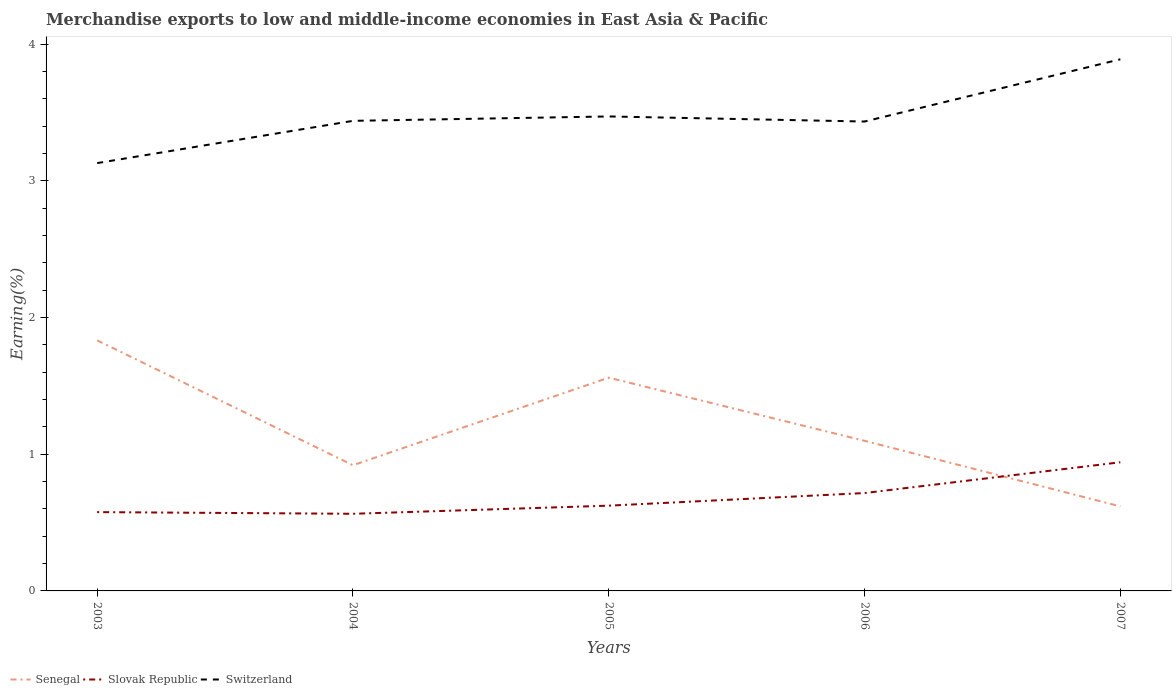How many different coloured lines are there?
Provide a succinct answer. 3. Does the line corresponding to Slovak Republic intersect with the line corresponding to Senegal?
Ensure brevity in your answer.  Yes. Is the number of lines equal to the number of legend labels?
Ensure brevity in your answer.  Yes. Across all years, what is the maximum percentage of amount earned from merchandise exports in Senegal?
Keep it short and to the point. 0.62. What is the total percentage of amount earned from merchandise exports in Switzerland in the graph?
Ensure brevity in your answer.  -0.46. What is the difference between the highest and the second highest percentage of amount earned from merchandise exports in Switzerland?
Provide a short and direct response. 0.76. What is the difference between two consecutive major ticks on the Y-axis?
Your response must be concise. 1. Where does the legend appear in the graph?
Offer a terse response. Bottom left. How many legend labels are there?
Make the answer very short. 3. How are the legend labels stacked?
Offer a very short reply. Horizontal. What is the title of the graph?
Keep it short and to the point. Merchandise exports to low and middle-income economies in East Asia & Pacific. What is the label or title of the X-axis?
Provide a short and direct response. Years. What is the label or title of the Y-axis?
Provide a short and direct response. Earning(%). What is the Earning(%) of Senegal in 2003?
Your response must be concise. 1.83. What is the Earning(%) in Slovak Republic in 2003?
Offer a terse response. 0.58. What is the Earning(%) in Switzerland in 2003?
Ensure brevity in your answer.  3.13. What is the Earning(%) of Senegal in 2004?
Ensure brevity in your answer.  0.92. What is the Earning(%) of Slovak Republic in 2004?
Ensure brevity in your answer.  0.56. What is the Earning(%) of Switzerland in 2004?
Your response must be concise. 3.44. What is the Earning(%) of Senegal in 2005?
Your answer should be very brief. 1.56. What is the Earning(%) of Slovak Republic in 2005?
Provide a short and direct response. 0.62. What is the Earning(%) of Switzerland in 2005?
Ensure brevity in your answer.  3.47. What is the Earning(%) in Senegal in 2006?
Provide a succinct answer. 1.1. What is the Earning(%) in Slovak Republic in 2006?
Give a very brief answer. 0.72. What is the Earning(%) of Switzerland in 2006?
Ensure brevity in your answer.  3.43. What is the Earning(%) of Senegal in 2007?
Your response must be concise. 0.62. What is the Earning(%) in Slovak Republic in 2007?
Your response must be concise. 0.94. What is the Earning(%) in Switzerland in 2007?
Make the answer very short. 3.89. Across all years, what is the maximum Earning(%) of Senegal?
Keep it short and to the point. 1.83. Across all years, what is the maximum Earning(%) of Slovak Republic?
Provide a short and direct response. 0.94. Across all years, what is the maximum Earning(%) of Switzerland?
Your answer should be very brief. 3.89. Across all years, what is the minimum Earning(%) of Senegal?
Your answer should be compact. 0.62. Across all years, what is the minimum Earning(%) in Slovak Republic?
Make the answer very short. 0.56. Across all years, what is the minimum Earning(%) of Switzerland?
Your answer should be compact. 3.13. What is the total Earning(%) of Senegal in the graph?
Give a very brief answer. 6.03. What is the total Earning(%) of Slovak Republic in the graph?
Your answer should be compact. 3.42. What is the total Earning(%) of Switzerland in the graph?
Your answer should be compact. 17.36. What is the difference between the Earning(%) in Senegal in 2003 and that in 2004?
Your answer should be compact. 0.91. What is the difference between the Earning(%) of Slovak Republic in 2003 and that in 2004?
Ensure brevity in your answer.  0.01. What is the difference between the Earning(%) in Switzerland in 2003 and that in 2004?
Provide a succinct answer. -0.31. What is the difference between the Earning(%) in Senegal in 2003 and that in 2005?
Offer a very short reply. 0.27. What is the difference between the Earning(%) of Slovak Republic in 2003 and that in 2005?
Offer a terse response. -0.05. What is the difference between the Earning(%) in Switzerland in 2003 and that in 2005?
Make the answer very short. -0.34. What is the difference between the Earning(%) of Senegal in 2003 and that in 2006?
Provide a succinct answer. 0.73. What is the difference between the Earning(%) of Slovak Republic in 2003 and that in 2006?
Give a very brief answer. -0.14. What is the difference between the Earning(%) of Switzerland in 2003 and that in 2006?
Your response must be concise. -0.3. What is the difference between the Earning(%) of Senegal in 2003 and that in 2007?
Give a very brief answer. 1.21. What is the difference between the Earning(%) of Slovak Republic in 2003 and that in 2007?
Your response must be concise. -0.36. What is the difference between the Earning(%) of Switzerland in 2003 and that in 2007?
Your answer should be very brief. -0.76. What is the difference between the Earning(%) in Senegal in 2004 and that in 2005?
Ensure brevity in your answer.  -0.64. What is the difference between the Earning(%) in Slovak Republic in 2004 and that in 2005?
Provide a short and direct response. -0.06. What is the difference between the Earning(%) of Switzerland in 2004 and that in 2005?
Make the answer very short. -0.03. What is the difference between the Earning(%) in Senegal in 2004 and that in 2006?
Provide a succinct answer. -0.18. What is the difference between the Earning(%) of Slovak Republic in 2004 and that in 2006?
Offer a very short reply. -0.15. What is the difference between the Earning(%) in Switzerland in 2004 and that in 2006?
Your answer should be compact. 0.01. What is the difference between the Earning(%) in Senegal in 2004 and that in 2007?
Keep it short and to the point. 0.3. What is the difference between the Earning(%) of Slovak Republic in 2004 and that in 2007?
Give a very brief answer. -0.38. What is the difference between the Earning(%) of Switzerland in 2004 and that in 2007?
Ensure brevity in your answer.  -0.45. What is the difference between the Earning(%) in Senegal in 2005 and that in 2006?
Ensure brevity in your answer.  0.46. What is the difference between the Earning(%) in Slovak Republic in 2005 and that in 2006?
Provide a short and direct response. -0.09. What is the difference between the Earning(%) of Switzerland in 2005 and that in 2006?
Make the answer very short. 0.04. What is the difference between the Earning(%) of Senegal in 2005 and that in 2007?
Offer a very short reply. 0.94. What is the difference between the Earning(%) in Slovak Republic in 2005 and that in 2007?
Offer a terse response. -0.32. What is the difference between the Earning(%) of Switzerland in 2005 and that in 2007?
Your answer should be very brief. -0.42. What is the difference between the Earning(%) of Senegal in 2006 and that in 2007?
Your answer should be very brief. 0.48. What is the difference between the Earning(%) in Slovak Republic in 2006 and that in 2007?
Make the answer very short. -0.23. What is the difference between the Earning(%) of Switzerland in 2006 and that in 2007?
Provide a succinct answer. -0.46. What is the difference between the Earning(%) in Senegal in 2003 and the Earning(%) in Slovak Republic in 2004?
Your answer should be compact. 1.27. What is the difference between the Earning(%) in Senegal in 2003 and the Earning(%) in Switzerland in 2004?
Ensure brevity in your answer.  -1.61. What is the difference between the Earning(%) in Slovak Republic in 2003 and the Earning(%) in Switzerland in 2004?
Offer a terse response. -2.86. What is the difference between the Earning(%) in Senegal in 2003 and the Earning(%) in Slovak Republic in 2005?
Offer a terse response. 1.21. What is the difference between the Earning(%) of Senegal in 2003 and the Earning(%) of Switzerland in 2005?
Offer a terse response. -1.64. What is the difference between the Earning(%) of Slovak Republic in 2003 and the Earning(%) of Switzerland in 2005?
Ensure brevity in your answer.  -2.89. What is the difference between the Earning(%) in Senegal in 2003 and the Earning(%) in Slovak Republic in 2006?
Offer a terse response. 1.12. What is the difference between the Earning(%) in Senegal in 2003 and the Earning(%) in Switzerland in 2006?
Offer a terse response. -1.6. What is the difference between the Earning(%) of Slovak Republic in 2003 and the Earning(%) of Switzerland in 2006?
Your response must be concise. -2.86. What is the difference between the Earning(%) of Senegal in 2003 and the Earning(%) of Slovak Republic in 2007?
Your response must be concise. 0.89. What is the difference between the Earning(%) of Senegal in 2003 and the Earning(%) of Switzerland in 2007?
Offer a terse response. -2.06. What is the difference between the Earning(%) of Slovak Republic in 2003 and the Earning(%) of Switzerland in 2007?
Offer a terse response. -3.31. What is the difference between the Earning(%) of Senegal in 2004 and the Earning(%) of Slovak Republic in 2005?
Provide a short and direct response. 0.3. What is the difference between the Earning(%) in Senegal in 2004 and the Earning(%) in Switzerland in 2005?
Your answer should be very brief. -2.55. What is the difference between the Earning(%) in Slovak Republic in 2004 and the Earning(%) in Switzerland in 2005?
Make the answer very short. -2.91. What is the difference between the Earning(%) in Senegal in 2004 and the Earning(%) in Slovak Republic in 2006?
Offer a very short reply. 0.2. What is the difference between the Earning(%) in Senegal in 2004 and the Earning(%) in Switzerland in 2006?
Your response must be concise. -2.51. What is the difference between the Earning(%) of Slovak Republic in 2004 and the Earning(%) of Switzerland in 2006?
Offer a terse response. -2.87. What is the difference between the Earning(%) in Senegal in 2004 and the Earning(%) in Slovak Republic in 2007?
Offer a terse response. -0.02. What is the difference between the Earning(%) in Senegal in 2004 and the Earning(%) in Switzerland in 2007?
Offer a terse response. -2.97. What is the difference between the Earning(%) in Slovak Republic in 2004 and the Earning(%) in Switzerland in 2007?
Your answer should be very brief. -3.32. What is the difference between the Earning(%) in Senegal in 2005 and the Earning(%) in Slovak Republic in 2006?
Make the answer very short. 0.84. What is the difference between the Earning(%) of Senegal in 2005 and the Earning(%) of Switzerland in 2006?
Your answer should be very brief. -1.87. What is the difference between the Earning(%) of Slovak Republic in 2005 and the Earning(%) of Switzerland in 2006?
Offer a terse response. -2.81. What is the difference between the Earning(%) in Senegal in 2005 and the Earning(%) in Slovak Republic in 2007?
Give a very brief answer. 0.62. What is the difference between the Earning(%) of Senegal in 2005 and the Earning(%) of Switzerland in 2007?
Offer a terse response. -2.33. What is the difference between the Earning(%) in Slovak Republic in 2005 and the Earning(%) in Switzerland in 2007?
Ensure brevity in your answer.  -3.27. What is the difference between the Earning(%) of Senegal in 2006 and the Earning(%) of Slovak Republic in 2007?
Provide a succinct answer. 0.16. What is the difference between the Earning(%) in Senegal in 2006 and the Earning(%) in Switzerland in 2007?
Make the answer very short. -2.79. What is the difference between the Earning(%) in Slovak Republic in 2006 and the Earning(%) in Switzerland in 2007?
Provide a succinct answer. -3.17. What is the average Earning(%) of Senegal per year?
Ensure brevity in your answer.  1.21. What is the average Earning(%) of Slovak Republic per year?
Your response must be concise. 0.68. What is the average Earning(%) of Switzerland per year?
Offer a very short reply. 3.47. In the year 2003, what is the difference between the Earning(%) of Senegal and Earning(%) of Slovak Republic?
Your response must be concise. 1.26. In the year 2003, what is the difference between the Earning(%) in Senegal and Earning(%) in Switzerland?
Give a very brief answer. -1.3. In the year 2003, what is the difference between the Earning(%) of Slovak Republic and Earning(%) of Switzerland?
Your response must be concise. -2.55. In the year 2004, what is the difference between the Earning(%) of Senegal and Earning(%) of Slovak Republic?
Make the answer very short. 0.36. In the year 2004, what is the difference between the Earning(%) of Senegal and Earning(%) of Switzerland?
Ensure brevity in your answer.  -2.52. In the year 2004, what is the difference between the Earning(%) in Slovak Republic and Earning(%) in Switzerland?
Ensure brevity in your answer.  -2.87. In the year 2005, what is the difference between the Earning(%) of Senegal and Earning(%) of Slovak Republic?
Provide a short and direct response. 0.94. In the year 2005, what is the difference between the Earning(%) of Senegal and Earning(%) of Switzerland?
Make the answer very short. -1.91. In the year 2005, what is the difference between the Earning(%) in Slovak Republic and Earning(%) in Switzerland?
Offer a terse response. -2.85. In the year 2006, what is the difference between the Earning(%) in Senegal and Earning(%) in Slovak Republic?
Your answer should be compact. 0.38. In the year 2006, what is the difference between the Earning(%) in Senegal and Earning(%) in Switzerland?
Provide a short and direct response. -2.34. In the year 2006, what is the difference between the Earning(%) of Slovak Republic and Earning(%) of Switzerland?
Keep it short and to the point. -2.72. In the year 2007, what is the difference between the Earning(%) of Senegal and Earning(%) of Slovak Republic?
Ensure brevity in your answer.  -0.32. In the year 2007, what is the difference between the Earning(%) of Senegal and Earning(%) of Switzerland?
Provide a short and direct response. -3.27. In the year 2007, what is the difference between the Earning(%) in Slovak Republic and Earning(%) in Switzerland?
Your answer should be compact. -2.95. What is the ratio of the Earning(%) in Senegal in 2003 to that in 2004?
Your answer should be very brief. 1.99. What is the ratio of the Earning(%) of Slovak Republic in 2003 to that in 2004?
Offer a very short reply. 1.02. What is the ratio of the Earning(%) in Switzerland in 2003 to that in 2004?
Ensure brevity in your answer.  0.91. What is the ratio of the Earning(%) in Senegal in 2003 to that in 2005?
Offer a terse response. 1.17. What is the ratio of the Earning(%) of Slovak Republic in 2003 to that in 2005?
Offer a terse response. 0.92. What is the ratio of the Earning(%) in Switzerland in 2003 to that in 2005?
Your response must be concise. 0.9. What is the ratio of the Earning(%) in Senegal in 2003 to that in 2006?
Your answer should be very brief. 1.67. What is the ratio of the Earning(%) in Slovak Republic in 2003 to that in 2006?
Keep it short and to the point. 0.81. What is the ratio of the Earning(%) in Switzerland in 2003 to that in 2006?
Give a very brief answer. 0.91. What is the ratio of the Earning(%) of Senegal in 2003 to that in 2007?
Your answer should be very brief. 2.96. What is the ratio of the Earning(%) in Slovak Republic in 2003 to that in 2007?
Keep it short and to the point. 0.61. What is the ratio of the Earning(%) of Switzerland in 2003 to that in 2007?
Your answer should be compact. 0.8. What is the ratio of the Earning(%) in Senegal in 2004 to that in 2005?
Give a very brief answer. 0.59. What is the ratio of the Earning(%) of Slovak Republic in 2004 to that in 2005?
Offer a terse response. 0.9. What is the ratio of the Earning(%) of Senegal in 2004 to that in 2006?
Make the answer very short. 0.84. What is the ratio of the Earning(%) of Slovak Republic in 2004 to that in 2006?
Give a very brief answer. 0.79. What is the ratio of the Earning(%) of Switzerland in 2004 to that in 2006?
Keep it short and to the point. 1. What is the ratio of the Earning(%) in Senegal in 2004 to that in 2007?
Keep it short and to the point. 1.49. What is the ratio of the Earning(%) of Slovak Republic in 2004 to that in 2007?
Make the answer very short. 0.6. What is the ratio of the Earning(%) of Switzerland in 2004 to that in 2007?
Provide a short and direct response. 0.88. What is the ratio of the Earning(%) of Senegal in 2005 to that in 2006?
Offer a terse response. 1.42. What is the ratio of the Earning(%) in Slovak Republic in 2005 to that in 2006?
Your response must be concise. 0.87. What is the ratio of the Earning(%) in Switzerland in 2005 to that in 2006?
Your response must be concise. 1.01. What is the ratio of the Earning(%) in Senegal in 2005 to that in 2007?
Provide a short and direct response. 2.52. What is the ratio of the Earning(%) of Slovak Republic in 2005 to that in 2007?
Your response must be concise. 0.66. What is the ratio of the Earning(%) of Switzerland in 2005 to that in 2007?
Your response must be concise. 0.89. What is the ratio of the Earning(%) of Senegal in 2006 to that in 2007?
Offer a very short reply. 1.78. What is the ratio of the Earning(%) in Slovak Republic in 2006 to that in 2007?
Ensure brevity in your answer.  0.76. What is the ratio of the Earning(%) of Switzerland in 2006 to that in 2007?
Your response must be concise. 0.88. What is the difference between the highest and the second highest Earning(%) of Senegal?
Provide a succinct answer. 0.27. What is the difference between the highest and the second highest Earning(%) in Slovak Republic?
Offer a terse response. 0.23. What is the difference between the highest and the second highest Earning(%) of Switzerland?
Offer a terse response. 0.42. What is the difference between the highest and the lowest Earning(%) in Senegal?
Provide a succinct answer. 1.21. What is the difference between the highest and the lowest Earning(%) of Slovak Republic?
Ensure brevity in your answer.  0.38. What is the difference between the highest and the lowest Earning(%) in Switzerland?
Give a very brief answer. 0.76. 